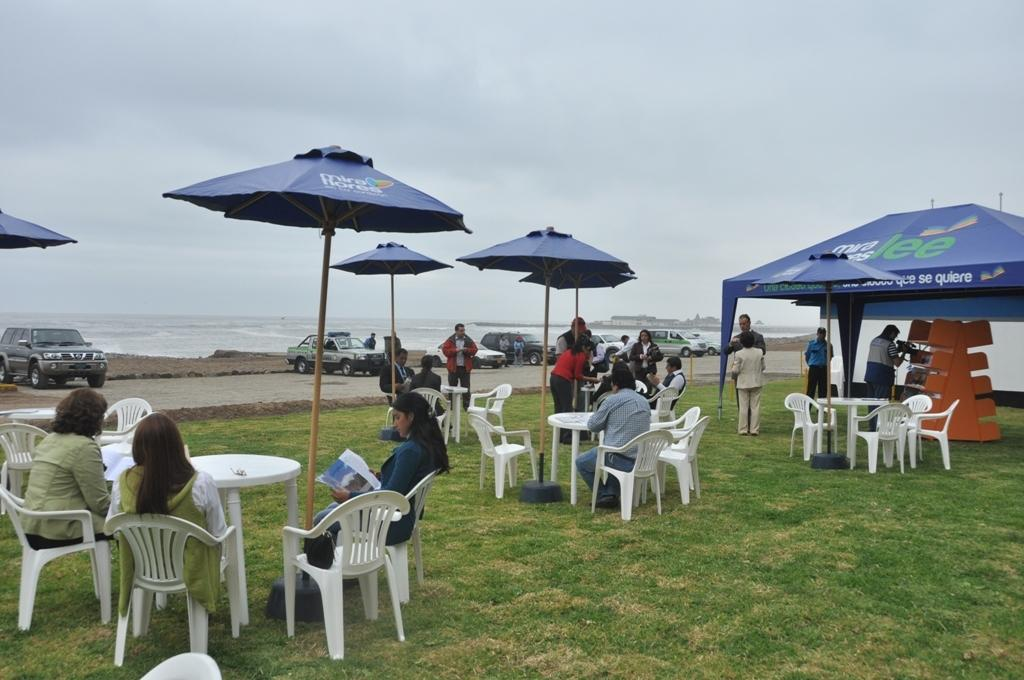What type of objects are the humans interacting with in the image? The humans are interacting with tables, chairs, and umbrellas in the image. What is the purpose of the umbrellas in the image? The umbrellas are likely being used to provide shade or shelter from the sun or rain. What is the setting of the image? The image features a waterfront setting, as water is visible in the image. What type of vehicles are present in the image? Cars are present in the image. What type of brass instrument is being played by the humans in the image? There is no brass instrument present in the image; the humans are not playing any musical instruments. What flavor of toothpaste is being used by the humans in the image? There is no toothpaste present in the image; the humans are not engaged in any personal hygiene activities. 